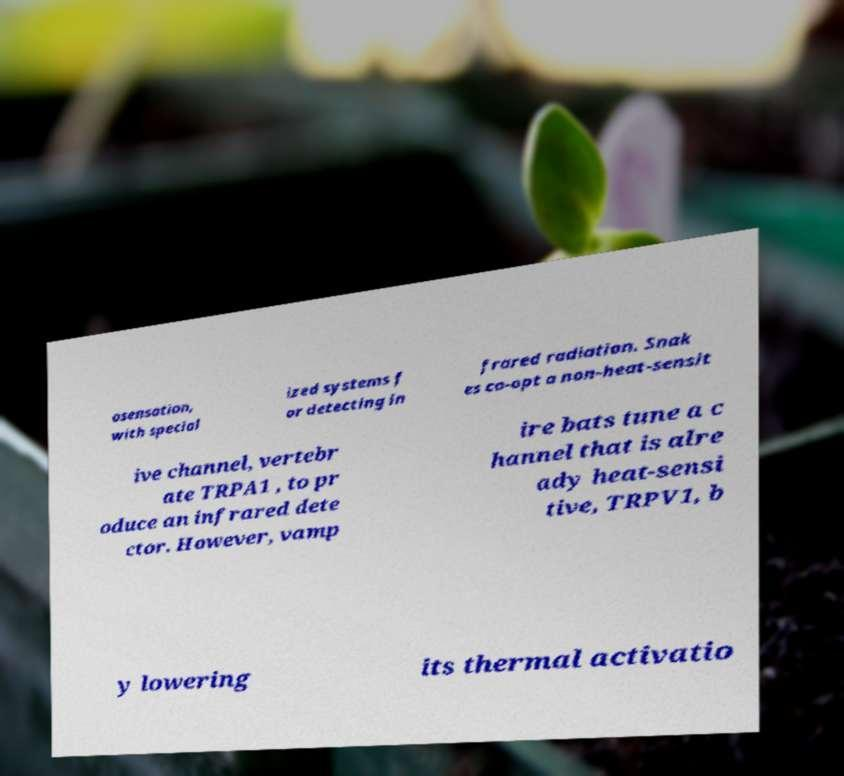For documentation purposes, I need the text within this image transcribed. Could you provide that? osensation, with special ized systems f or detecting in frared radiation. Snak es co-opt a non-heat-sensit ive channel, vertebr ate TRPA1 , to pr oduce an infrared dete ctor. However, vamp ire bats tune a c hannel that is alre ady heat-sensi tive, TRPV1, b y lowering its thermal activatio 